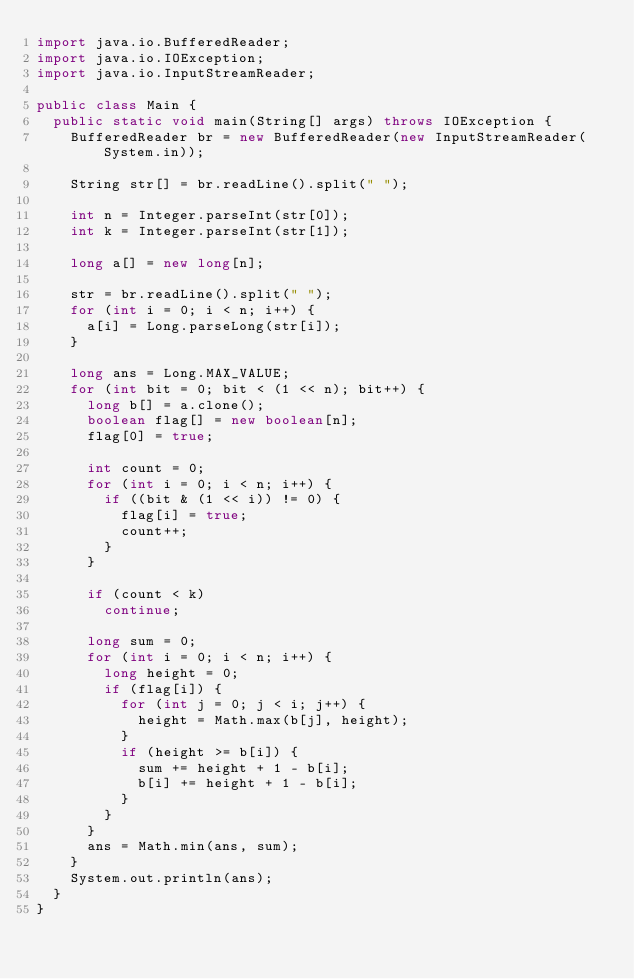Convert code to text. <code><loc_0><loc_0><loc_500><loc_500><_Java_>import java.io.BufferedReader;
import java.io.IOException;
import java.io.InputStreamReader;

public class Main {
	public static void main(String[] args) throws IOException {
		BufferedReader br = new BufferedReader(new InputStreamReader(System.in));

		String str[] = br.readLine().split(" ");

		int n = Integer.parseInt(str[0]);
		int k = Integer.parseInt(str[1]);

		long a[] = new long[n];

		str = br.readLine().split(" ");
		for (int i = 0; i < n; i++) {
			a[i] = Long.parseLong(str[i]);
		}

		long ans = Long.MAX_VALUE;
		for (int bit = 0; bit < (1 << n); bit++) {
			long b[] = a.clone();
			boolean flag[] = new boolean[n];
			flag[0] = true;

			int count = 0;
			for (int i = 0; i < n; i++) {
				if ((bit & (1 << i)) != 0) {
					flag[i] = true;
					count++;
				}
			}

			if (count < k)
				continue;

			long sum = 0;
			for (int i = 0; i < n; i++) {
				long height = 0;
				if (flag[i]) {
					for (int j = 0; j < i; j++) {
						height = Math.max(b[j], height);
					}
					if (height >= b[i]) {
						sum += height + 1 - b[i];
						b[i] += height + 1 - b[i];
					}
				}
			}
			ans = Math.min(ans, sum);
		}
		System.out.println(ans);
	}
}
</code> 